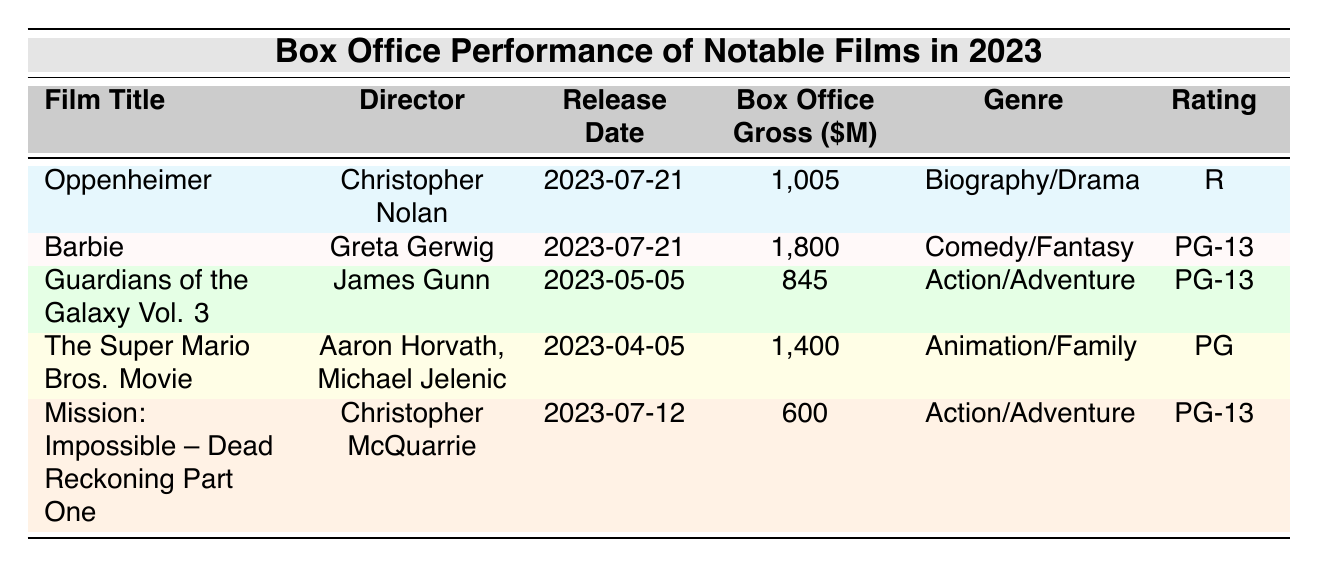What is the highest box office gross among the listed films? The table shows the box office grosses for each film. Among the values (1,005; 1,800; 845; 1,400; 600), the highest number is 1,800, which belongs to "Barbie."
Answer: 1,800 Who directed "Oppenheimer"? The table includes a column for the director of each film. For "Oppenheimer," the director listed is Christopher Nolan.
Answer: Christopher Nolan Which film has the lowest box office gross? The box office grosses from the table are: 1,005 (Oppenheimer), 1,800 (Barbie), 845 (Guardians of the Galaxy Vol. 3), 1,400 (The Super Mario Bros. Movie), and 600 (Mission: Impossible – Dead Reckoning Part One). The lowest value is 600, belonging to "Mission: Impossible – Dead Reckoning Part One."
Answer: Mission: Impossible – Dead Reckoning Part One Is "The Super Mario Bros. Movie" rated PG? The rating for "The Super Mario Bros. Movie," as indicated in the table, is indeed PG. Therefore, the statement is true.
Answer: Yes What is the average box office gross of the films directed by Christopher Nolan? Christopher Nolan directed one film, "Oppenheimer," which had a box office gross of 1,005 million dollars. Since there is only one film, the average is simply 1,005/1 = 1,005.
Answer: 1,005 Which film genres are represented in the table? The genres listed are Biography/Drama (Oppenheimer), Comedy/Fantasy (Barbie), Action/Adventure (Guardians of the Galaxy Vol. 3 and Mission: Impossible – Dead Reckoning Part One), and Animation/Family (The Super Mario Bros. Movie). Thus, the genres are Biography/Drama, Comedy/Fantasy, Action/Adventure, and Animation/Family.
Answer: Biography/Drama, Comedy/Fantasy, Action/Adventure, Animation/Family How much more did "Barbie" earn compared to "Guardians of the Galaxy Vol. 3"? "Barbie" grossed 1,800 million dollars and "Guardians of the Galaxy Vol. 3" grossed 845 million dollars. The difference is 1,800 - 845 = 955 million dollars.
Answer: 955 What percentage of the total box office gross is attributed to "Barbie"? The total box office gross for all films is 1,005 + 1,800 + 845 + 1,400 + 600 = 5,650 million dollars. "Barbie's" gross is 1,800 million dollars. To find the percentage, calculate (1,800 / 5,650) * 100, which equals approximately 31.7%.
Answer: 31.7% 